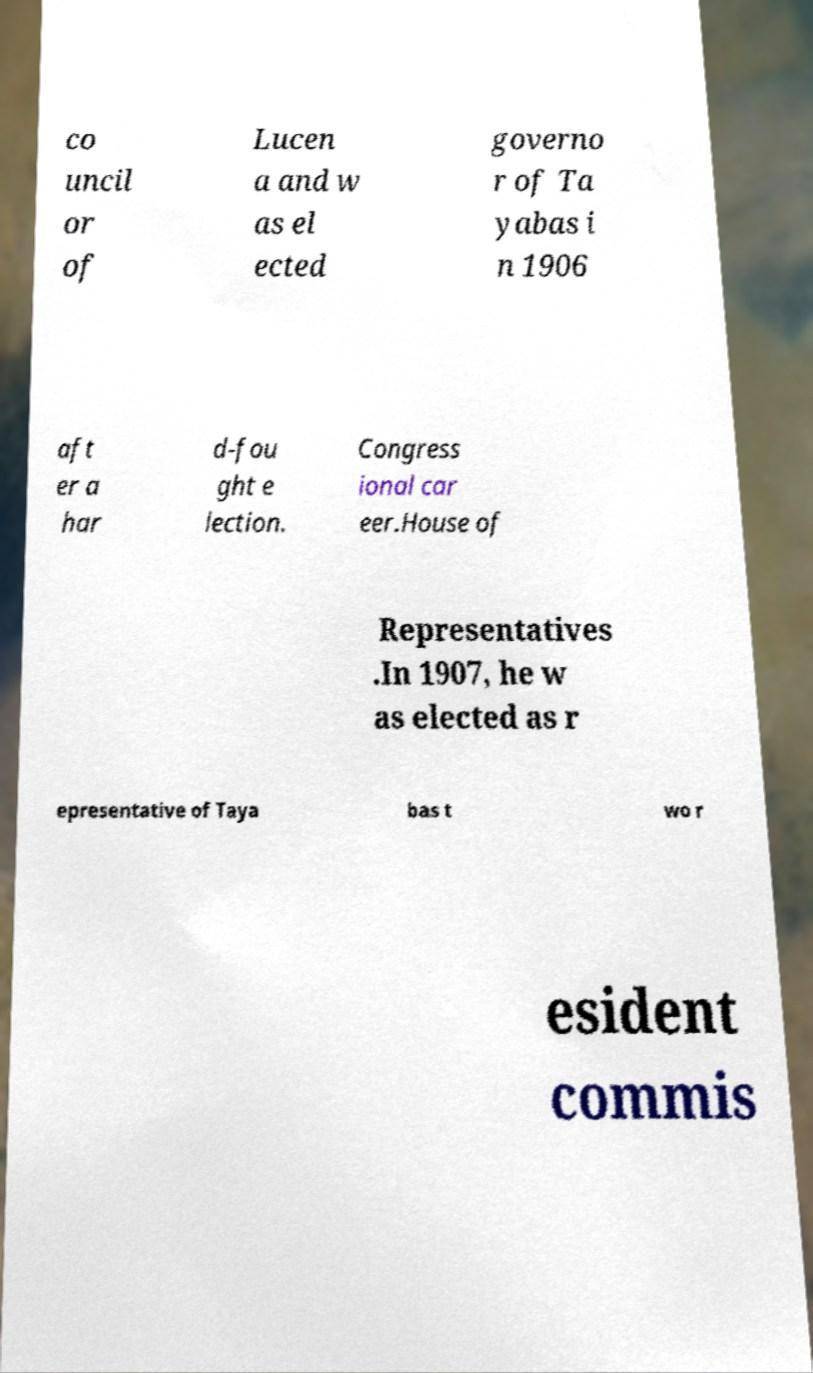Can you read and provide the text displayed in the image?This photo seems to have some interesting text. Can you extract and type it out for me? co uncil or of Lucen a and w as el ected governo r of Ta yabas i n 1906 aft er a har d-fou ght e lection. Congress ional car eer.House of Representatives .In 1907, he w as elected as r epresentative of Taya bas t wo r esident commis 